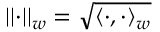<formula> <loc_0><loc_0><loc_500><loc_500>| | \cdot | | _ { w } = \sqrt { \langle \cdot , \cdot \rangle _ { w } }</formula> 